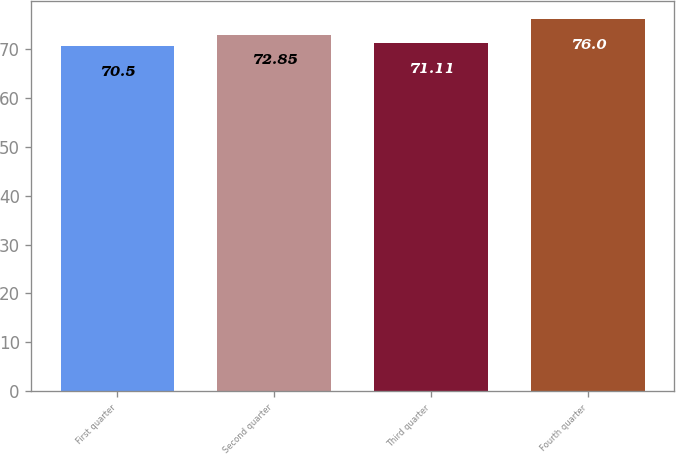Convert chart. <chart><loc_0><loc_0><loc_500><loc_500><bar_chart><fcel>First quarter<fcel>Second quarter<fcel>Third quarter<fcel>Fourth quarter<nl><fcel>70.5<fcel>72.85<fcel>71.11<fcel>76<nl></chart> 